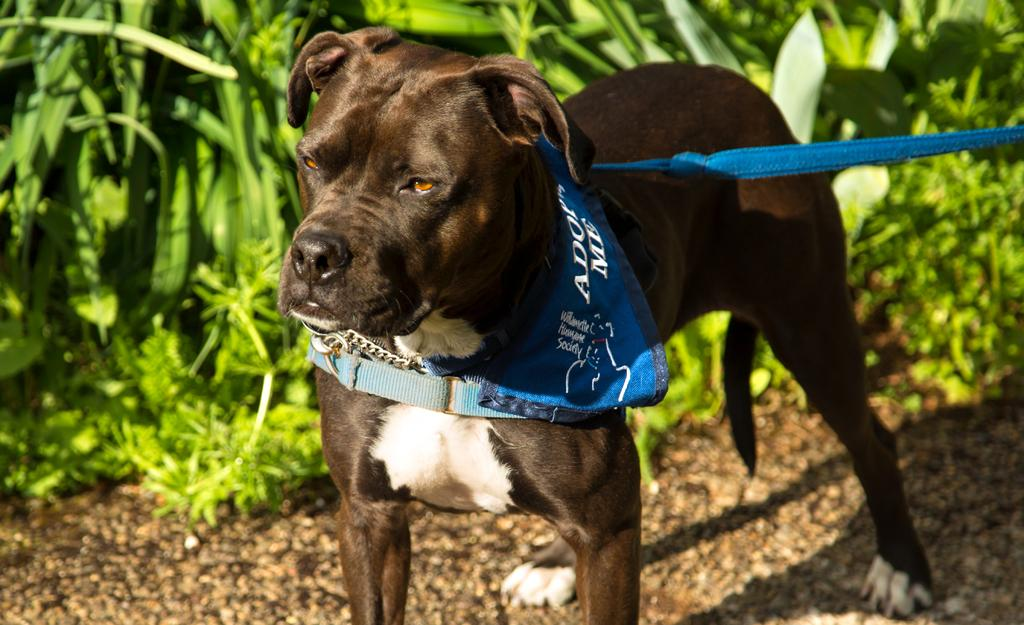What type of animal is present in the image? There is a dog in the image. Can you describe the appearance of the dog? The dog is white and brown in color. Is the dog wearing any accessories in the image? Yes, the dog is wearing a blue color belt. What can be seen in the background of the image? There are many plants in the background of the image. How many girls are holding the dog's leash in the image? There are no girls present in the image, and the dog is not shown to be on a leash. 